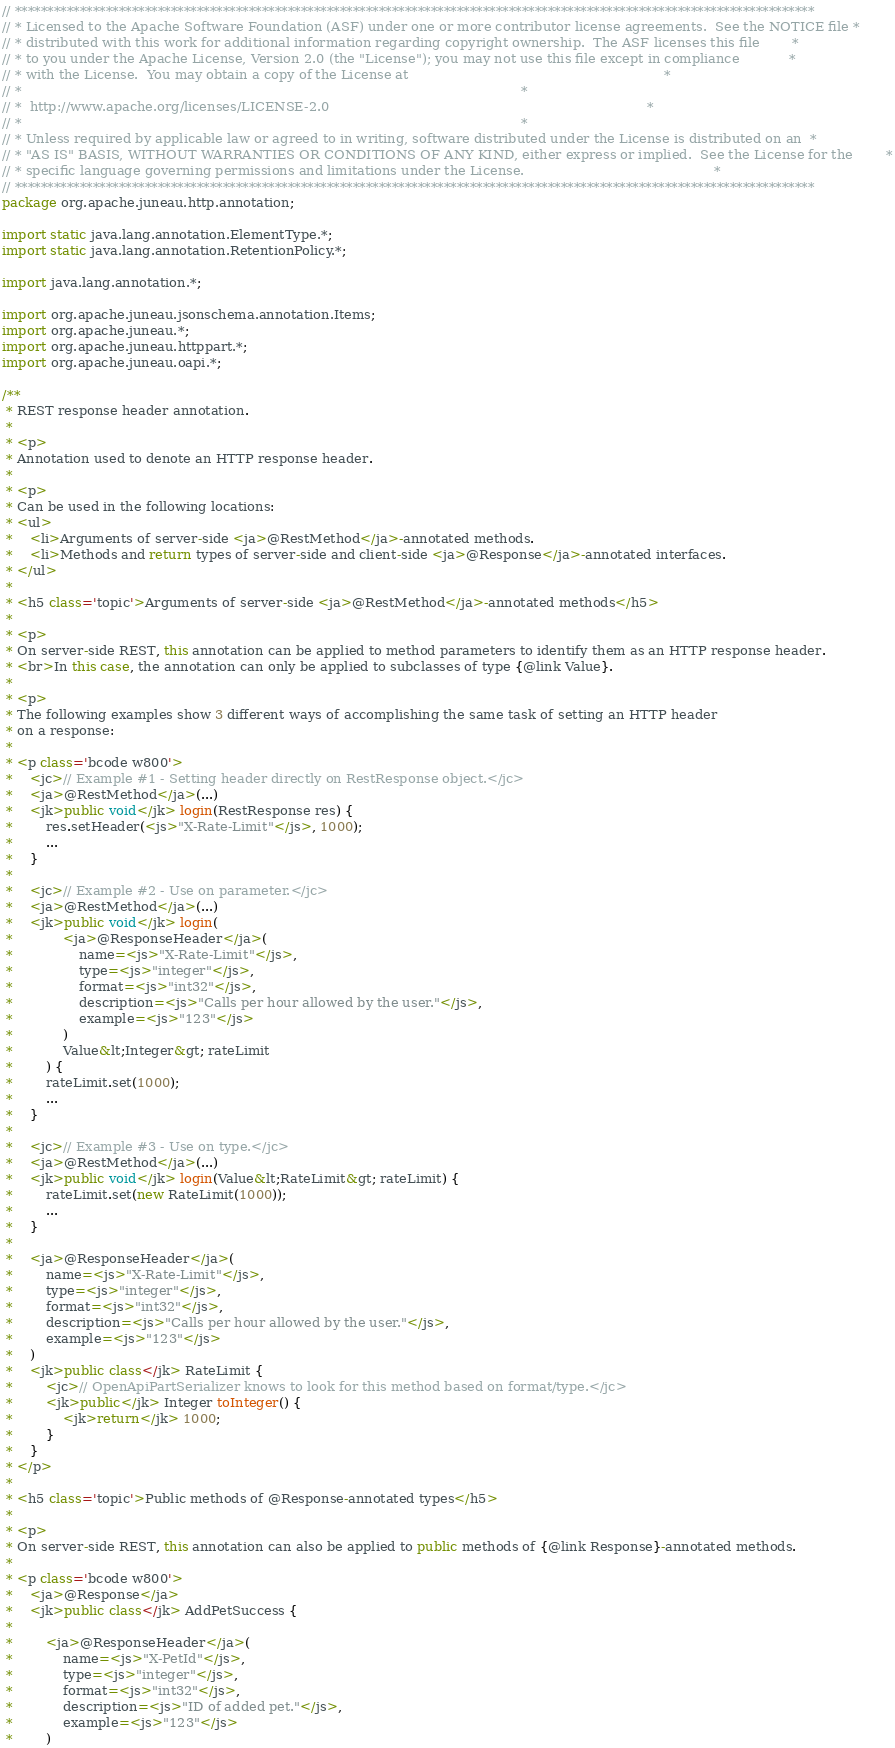Convert code to text. <code><loc_0><loc_0><loc_500><loc_500><_Java_>// ***************************************************************************************************************************
// * Licensed to the Apache Software Foundation (ASF) under one or more contributor license agreements.  See the NOTICE file *
// * distributed with this work for additional information regarding copyright ownership.  The ASF licenses this file        *
// * to you under the Apache License, Version 2.0 (the "License"); you may not use this file except in compliance            *
// * with the License.  You may obtain a copy of the License at                                                              *
// *                                                                                                                         *
// *  http://www.apache.org/licenses/LICENSE-2.0                                                                             *
// *                                                                                                                         *
// * Unless required by applicable law or agreed to in writing, software distributed under the License is distributed on an  *
// * "AS IS" BASIS, WITHOUT WARRANTIES OR CONDITIONS OF ANY KIND, either express or implied.  See the License for the        *
// * specific language governing permissions and limitations under the License.                                              *
// ***************************************************************************************************************************
package org.apache.juneau.http.annotation;

import static java.lang.annotation.ElementType.*;
import static java.lang.annotation.RetentionPolicy.*;

import java.lang.annotation.*;

import org.apache.juneau.jsonschema.annotation.Items;
import org.apache.juneau.*;
import org.apache.juneau.httppart.*;
import org.apache.juneau.oapi.*;

/**
 * REST response header annotation.
 *
 * <p>
 * Annotation used to denote an HTTP response header.
 *
 * <p>
 * Can be used in the following locations:
 * <ul>
 * 	<li>Arguments of server-side <ja>@RestMethod</ja>-annotated methods.
 * 	<li>Methods and return types of server-side and client-side <ja>@Response</ja>-annotated interfaces.
 * </ul>
 *
 * <h5 class='topic'>Arguments of server-side <ja>@RestMethod</ja>-annotated methods</h5>
 *
 * <p>
 * On server-side REST, this annotation can be applied to method parameters to identify them as an HTTP response header.
 * <br>In this case, the annotation can only be applied to subclasses of type {@link Value}.
 *
 * <p>
 * The following examples show 3 different ways of accomplishing the same task of setting an HTTP header
 * on a response:
 *
 * <p class='bcode w800'>
 * 	<jc>// Example #1 - Setting header directly on RestResponse object.</jc>
 * 	<ja>@RestMethod</ja>(...)
 * 	<jk>public void</jk> login(RestResponse res) {
 * 		res.setHeader(<js>"X-Rate-Limit"</js>, 1000);
 * 		...
 * 	}
 *
 *	<jc>// Example #2 - Use on parameter.</jc>
 * 	<ja>@RestMethod</ja>(...)
 * 	<jk>public void</jk> login(
 * 			<ja>@ResponseHeader</ja>(
 * 				name=<js>"X-Rate-Limit"</js>,
 * 				type=<js>"integer"</js>,
 * 				format=<js>"int32"</js>,
 * 				description=<js>"Calls per hour allowed by the user."</js>,
 * 				example=<js>"123"</js>
 * 			)
 * 			Value&lt;Integer&gt; rateLimit
 *		) {
 *		rateLimit.set(1000);
 *		...
 * 	}
 *
 *	<jc>// Example #3 - Use on type.</jc>
 * 	<ja>@RestMethod</ja>(...)
 * 	<jk>public void</jk> login(Value&lt;RateLimit&gt; rateLimit) {
 * 		rateLimit.set(new RateLimit(1000));
 * 		...
 * 	}
 *
 * 	<ja>@ResponseHeader</ja>(
 * 		name=<js>"X-Rate-Limit"</js>,
 * 		type=<js>"integer"</js>,
 * 		format=<js>"int32"</js>,
 * 		description=<js>"Calls per hour allowed by the user."</js>,
 * 		example=<js>"123"</js>
 * 	)
 * 	<jk>public class</jk> RateLimit {
 * 		<jc>// OpenApiPartSerializer knows to look for this method based on format/type.</jc>
 * 		<jk>public</jk> Integer toInteger() {
 * 			<jk>return</jk> 1000;
 * 		}
 * 	}
 * </p>
 *
 * <h5 class='topic'>Public methods of @Response-annotated types</h5>
 *
 * <p>
 * On server-side REST, this annotation can also be applied to public methods of {@link Response}-annotated methods.
 *
 * <p class='bcode w800'>
 * 	<ja>@Response</ja>
 * 	<jk>public class</jk> AddPetSuccess {
 *
 * 		<ja>@ResponseHeader</ja>(
 * 			name=<js>"X-PetId"</js>,
 * 			type=<js>"integer"</js>,
 * 			format=<js>"int32"</js>,
 * 			description=<js>"ID of added pet."</js>,
 * 			example=<js>"123"</js>
 * 		)</code> 